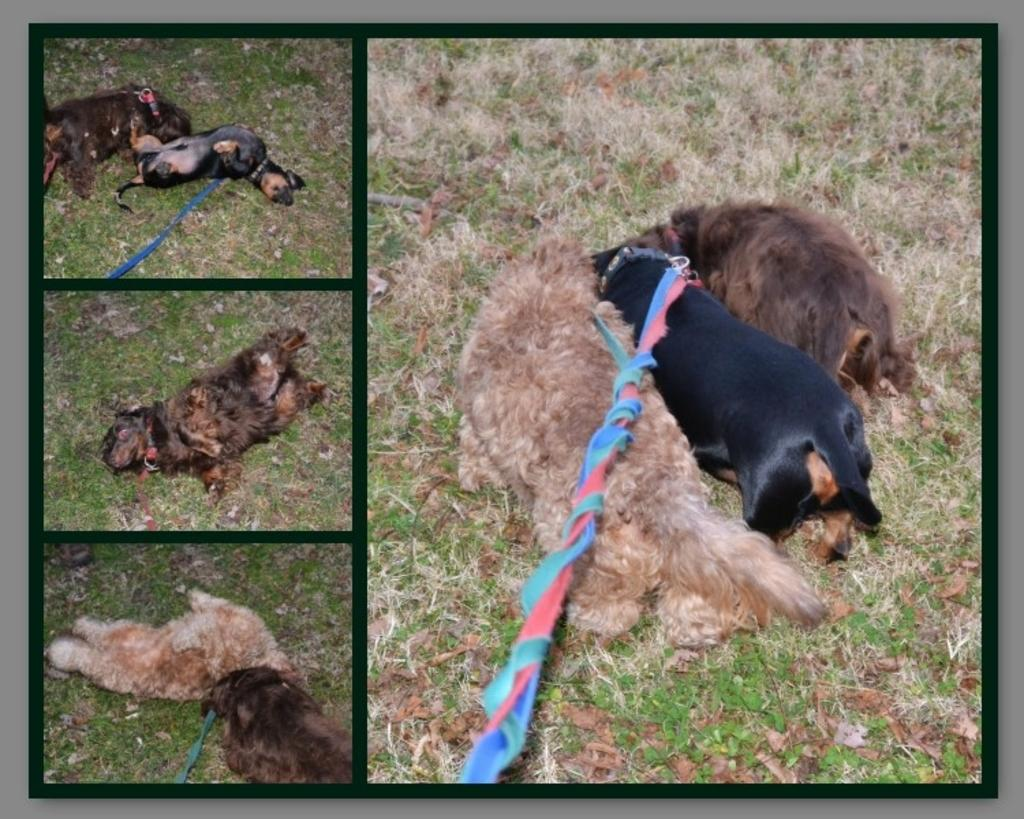What type of artwork is shown in the image? The image is a collage consisting of four pictures. How many pictures of dogs are in the collage? There are three pictures of dogs in the collage. Can you describe the content of the pictures in the collage? The pictures consist of different images of dogs. What type of salt can be seen on the mountain in the image? There is no salt or mountain present in the image; it consists of a collage of dog pictures. 